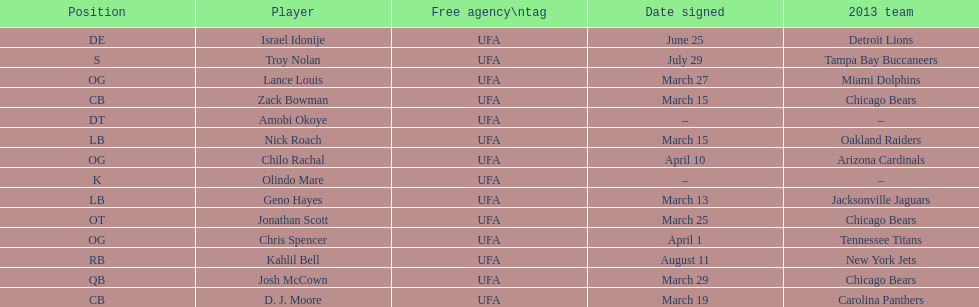His/her first name is the same name as a country. Israel Idonije. 